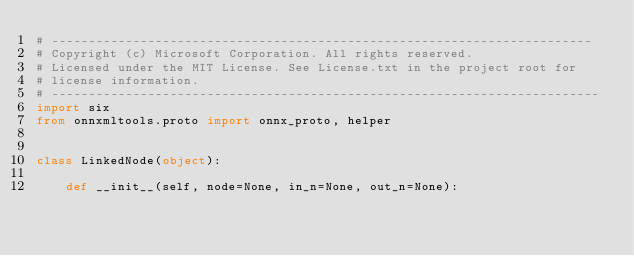Convert code to text. <code><loc_0><loc_0><loc_500><loc_500><_Python_># -------------------------------------------------------------------------
# Copyright (c) Microsoft Corporation. All rights reserved.
# Licensed under the MIT License. See License.txt in the project root for
# license information.
# --------------------------------------------------------------------------
import six
from onnxmltools.proto import onnx_proto, helper


class LinkedNode(object):

    def __init__(self, node=None, in_n=None, out_n=None):</code> 